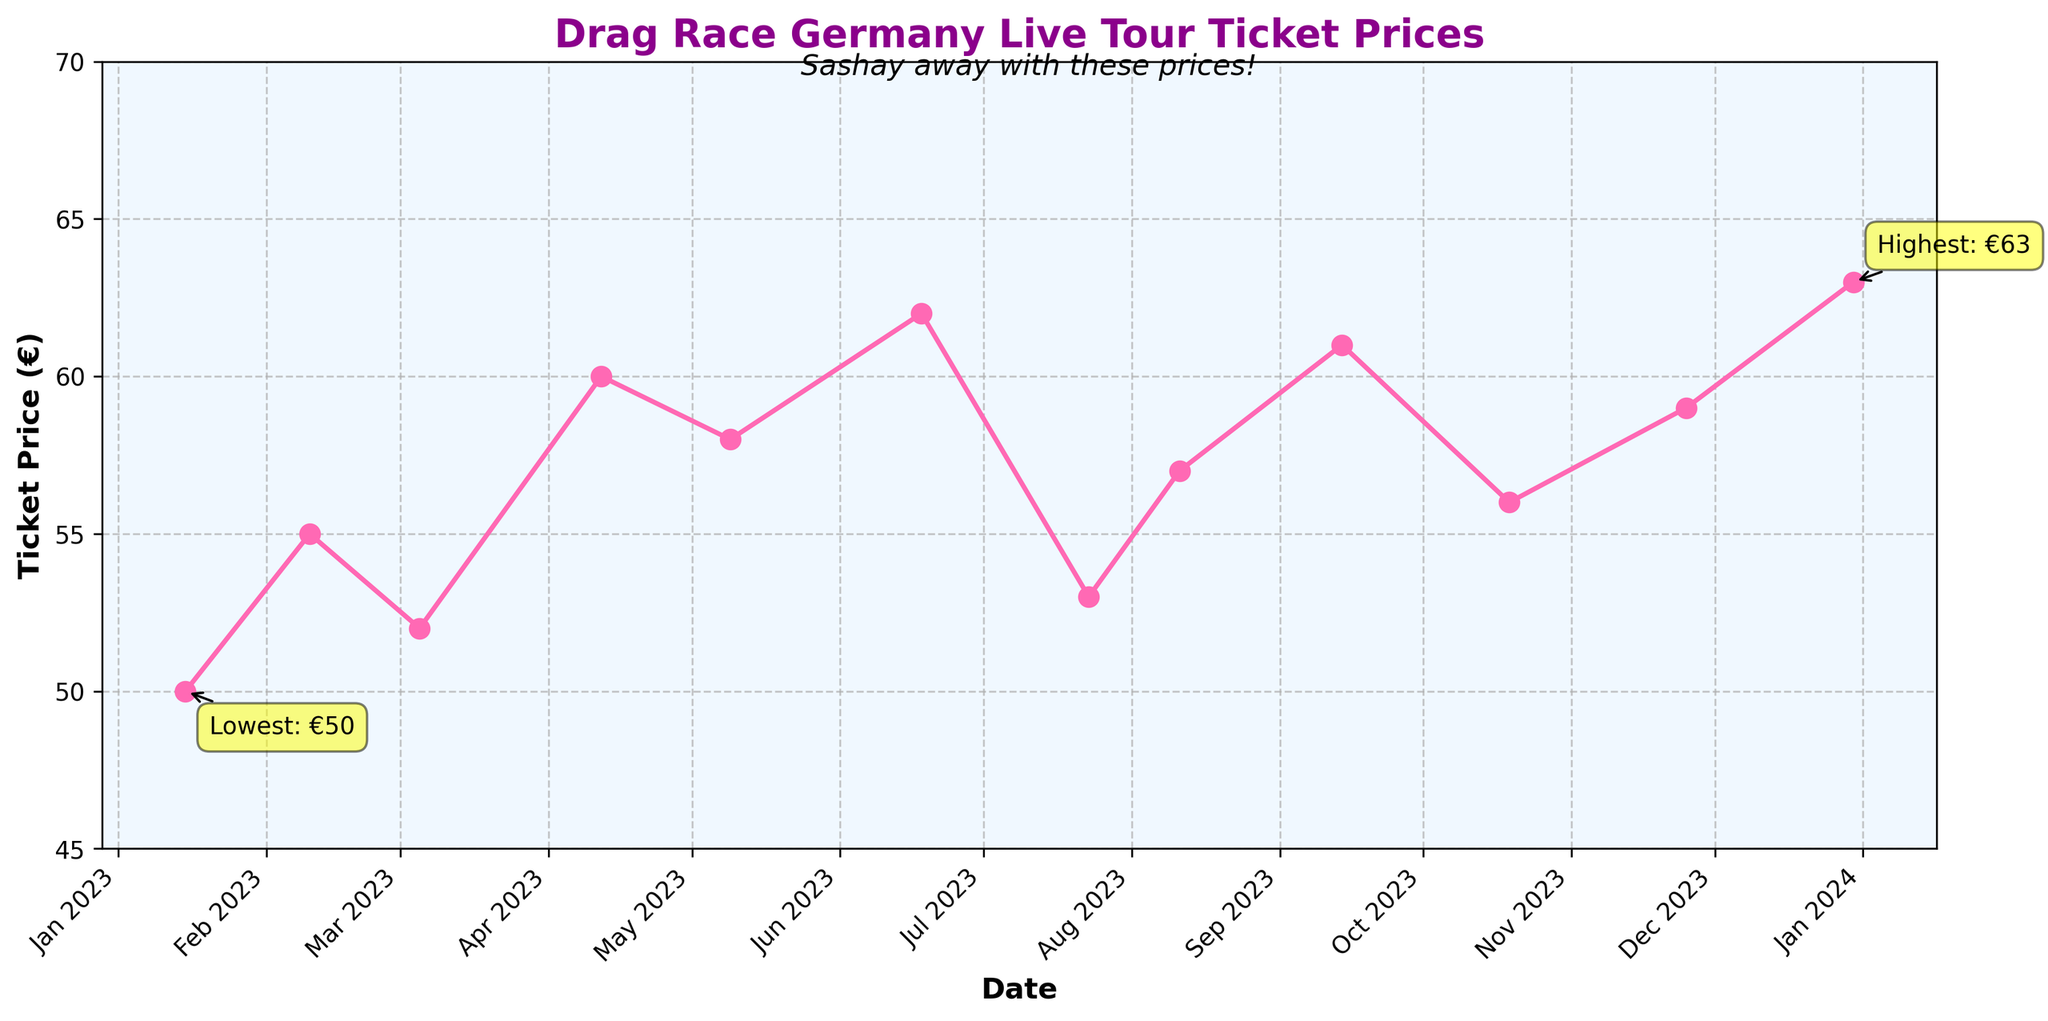What is the title of the plot? The title of the plot is prominently displayed at the top of the figure. It indicates what the plot is about.
Answer: Drag Race Germany Live Tour Ticket Prices What is the highest ticket price shown in the figure, and when was it recorded? The highest ticket price is annotated on the plot with a yellow box and an arrow pointing to the data point.
Answer: 63 €, December 2023 What is the lowest ticket price shown in the figure, and when was it recorded? The lowest ticket price is annotated on the plot with a yellow box and an arrow pointing to the data point.
Answer: 50 €, January 2023 How many major data points are plotted in the figure? Count the number of markers (data points) plotted on the line graph.
Answer: 12 Describe the trend of ticket prices between January 2023 and July 2023. The ticket price starts at 50 € in January 2023, peaks at 60 € in April 2023, and then decreases slightly to 53 € by July 2023.
Answer: Shows an increase, peaking at April, then a slight decrease What is the difference between the highest and lowest ticket prices? Subtract the lowest ticket price from the highest ticket price (63 € - 50 €).
Answer: 13 € On which dates were the ticket prices 57 € or higher? Identify all dates in the figure where the ticket price is annotated at 57 € or higher.
Answer: August 2023, September 2023, October 2023, November 2023, December 2023 What was the ticket price in Munich for the month of June and December 2023? Look at the data points specific to Munich in June and December 2023.
Answer: 62 €, June 2023 and 63 €, December 2023 